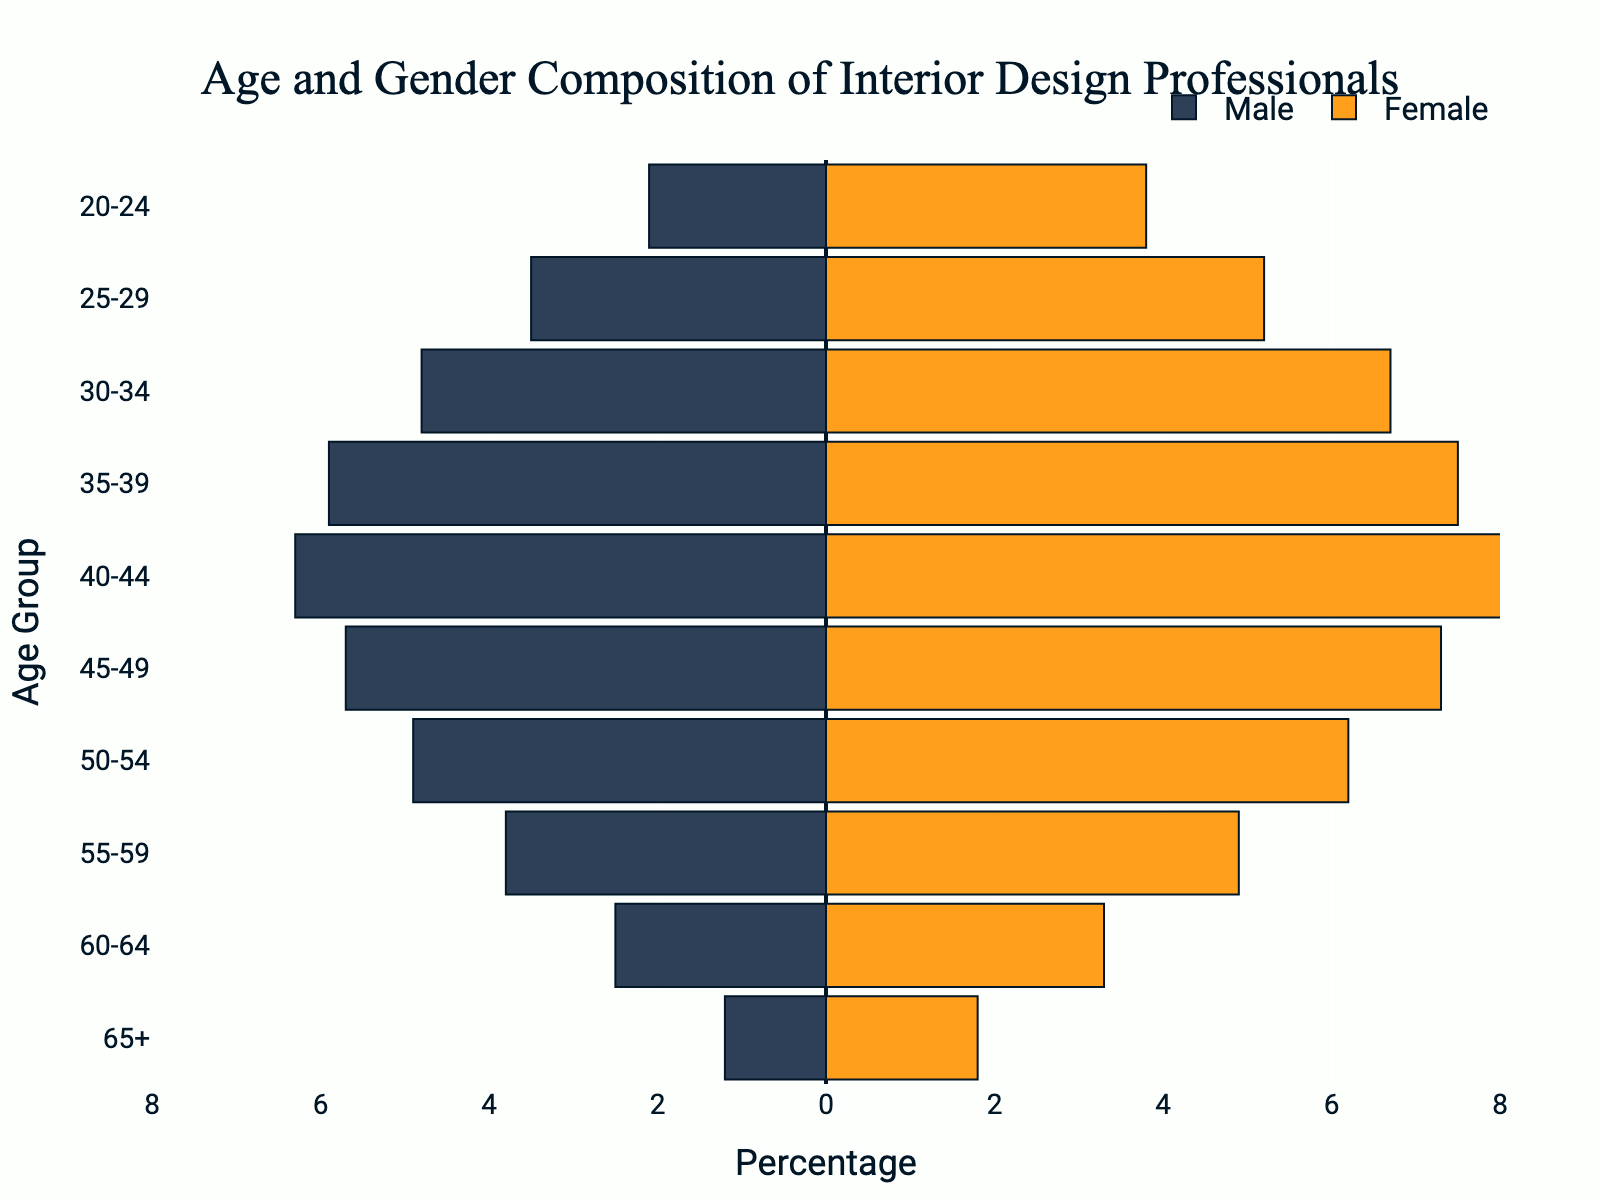What is the title of the figure? The title is located at the top of the figure and usually summarizes the main theme or topic being represented. In this case, it's clearly stated.
Answer: Age and Gender Composition of Interior Design Professionals What age group has the highest percentage of female professionals? By examining the pink bars, it is evident which age group has the longest bar on the positive (right) side of the graph.
Answer: 40-44 Which gender has a higher percentage in the 30-34 age group? By comparing the length of the blue bar (male) and the pink bar (female) for the 30-34 age group, the longer bar indicates the higher percentage.
Answer: Female How does the percentage of male professionals change as the age group increases from 20-24 to 45-49? To determine the change, observe the lengths of the blue bars across the mentioned age groups and note any trends whether they are increasing or decreasing.
Answer: Increases What is the combined percentage of male and female professionals in the 55-59 age group? Add the absolute values of the male and female percentages in the 55-59 age group together.
Answer: 8.7 How does the percentage difference between males and females change in the 45-49 and 50-54 age groups? Calculate the difference in percentages for males and females in each age group individually, then find the difference between these two values.
Answer: 1.7 Which age group has the smallest gender disparity? Identify the age group where the blue and pink bars are closest in length, indicating the smallest percentage difference between males and females.
Answer: 25-29 What is the trend in the percentage of female professionals from age group 25-29 to 50-54? Observe the pink bars and determine if they are generally increasing, decreasing, or remain constant as you move across the age groups from 25-29 to 50-54.
Answer: Increasing In the oldest age group (65+), how many times greater is the percentage of female professionals compared to male professionals? Calculate the ratio by dividing the percentage of female professionals by the percentage of male professionals in the 65+ age group.
Answer: 1.5 times What is the range of percentages for male professionals across all age groups? Identify the minimum and maximum percentages of male professionals, then find the range by subtracting the minimum from the maximum.
Answer: 1.2 to 6.3 